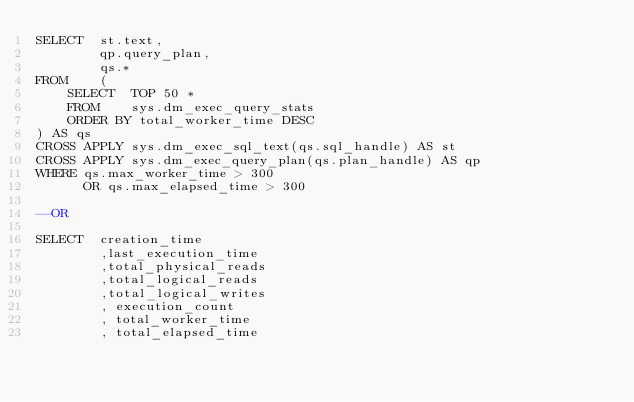Convert code to text. <code><loc_0><loc_0><loc_500><loc_500><_SQL_>SELECT  st.text,
        qp.query_plan,
        qs.*
FROM    (
    SELECT  TOP 50 *
    FROM    sys.dm_exec_query_stats
    ORDER BY total_worker_time DESC
) AS qs
CROSS APPLY sys.dm_exec_sql_text(qs.sql_handle) AS st
CROSS APPLY sys.dm_exec_query_plan(qs.plan_handle) AS qp
WHERE qs.max_worker_time > 300
      OR qs.max_elapsed_time > 300
	  
--OR

SELECT  creation_time 
        ,last_execution_time
        ,total_physical_reads
        ,total_logical_reads 
        ,total_logical_writes
        , execution_count
        , total_worker_time
        , total_elapsed_time</code> 